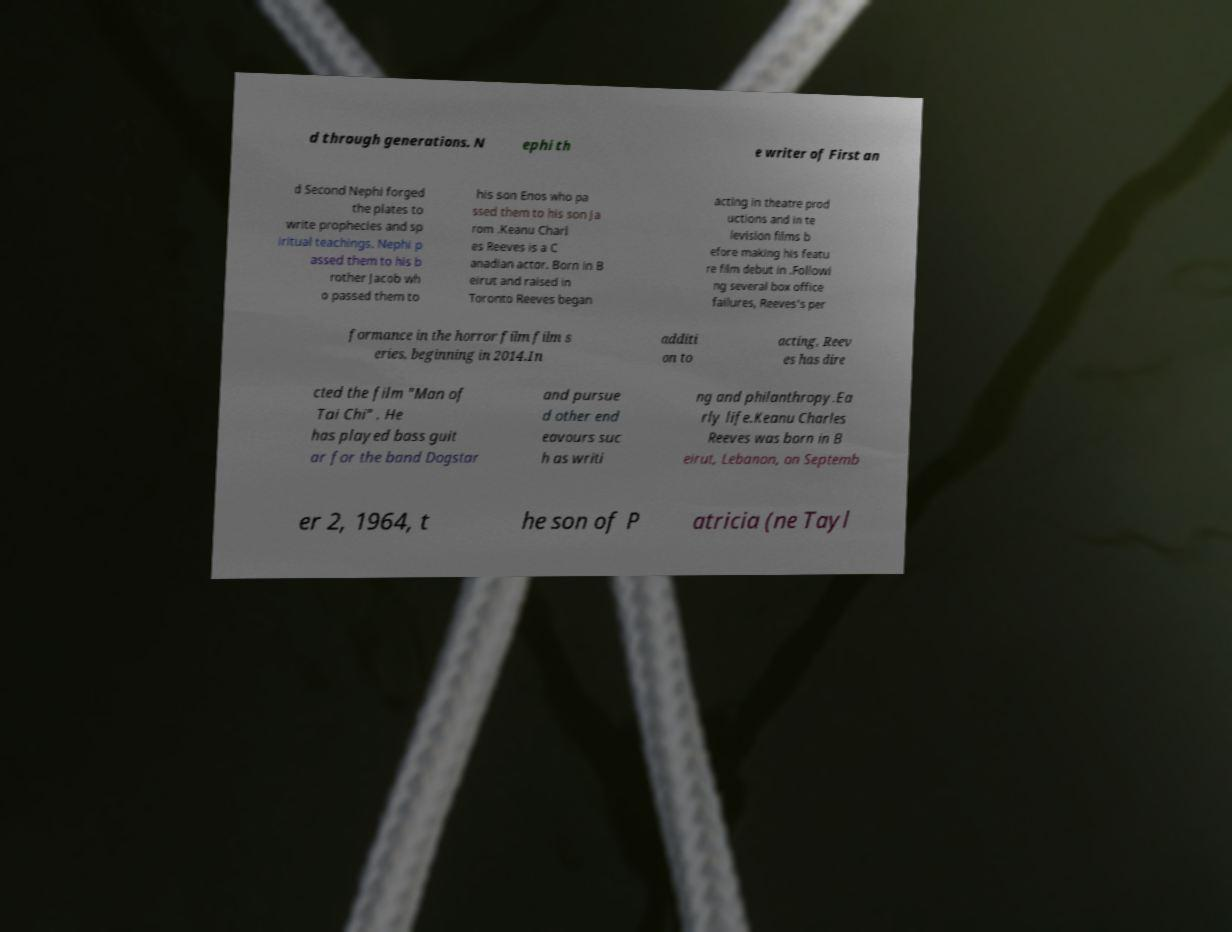Can you read and provide the text displayed in the image?This photo seems to have some interesting text. Can you extract and type it out for me? d through generations. N ephi th e writer of First an d Second Nephi forged the plates to write prophecies and sp iritual teachings. Nephi p assed them to his b rother Jacob wh o passed them to his son Enos who pa ssed them to his son Ja rom .Keanu Charl es Reeves is a C anadian actor. Born in B eirut and raised in Toronto Reeves began acting in theatre prod uctions and in te levision films b efore making his featu re film debut in .Followi ng several box office failures, Reeves's per formance in the horror film film s eries, beginning in 2014.In additi on to acting, Reev es has dire cted the film "Man of Tai Chi" . He has played bass guit ar for the band Dogstar and pursue d other end eavours suc h as writi ng and philanthropy.Ea rly life.Keanu Charles Reeves was born in B eirut, Lebanon, on Septemb er 2, 1964, t he son of P atricia (ne Tayl 